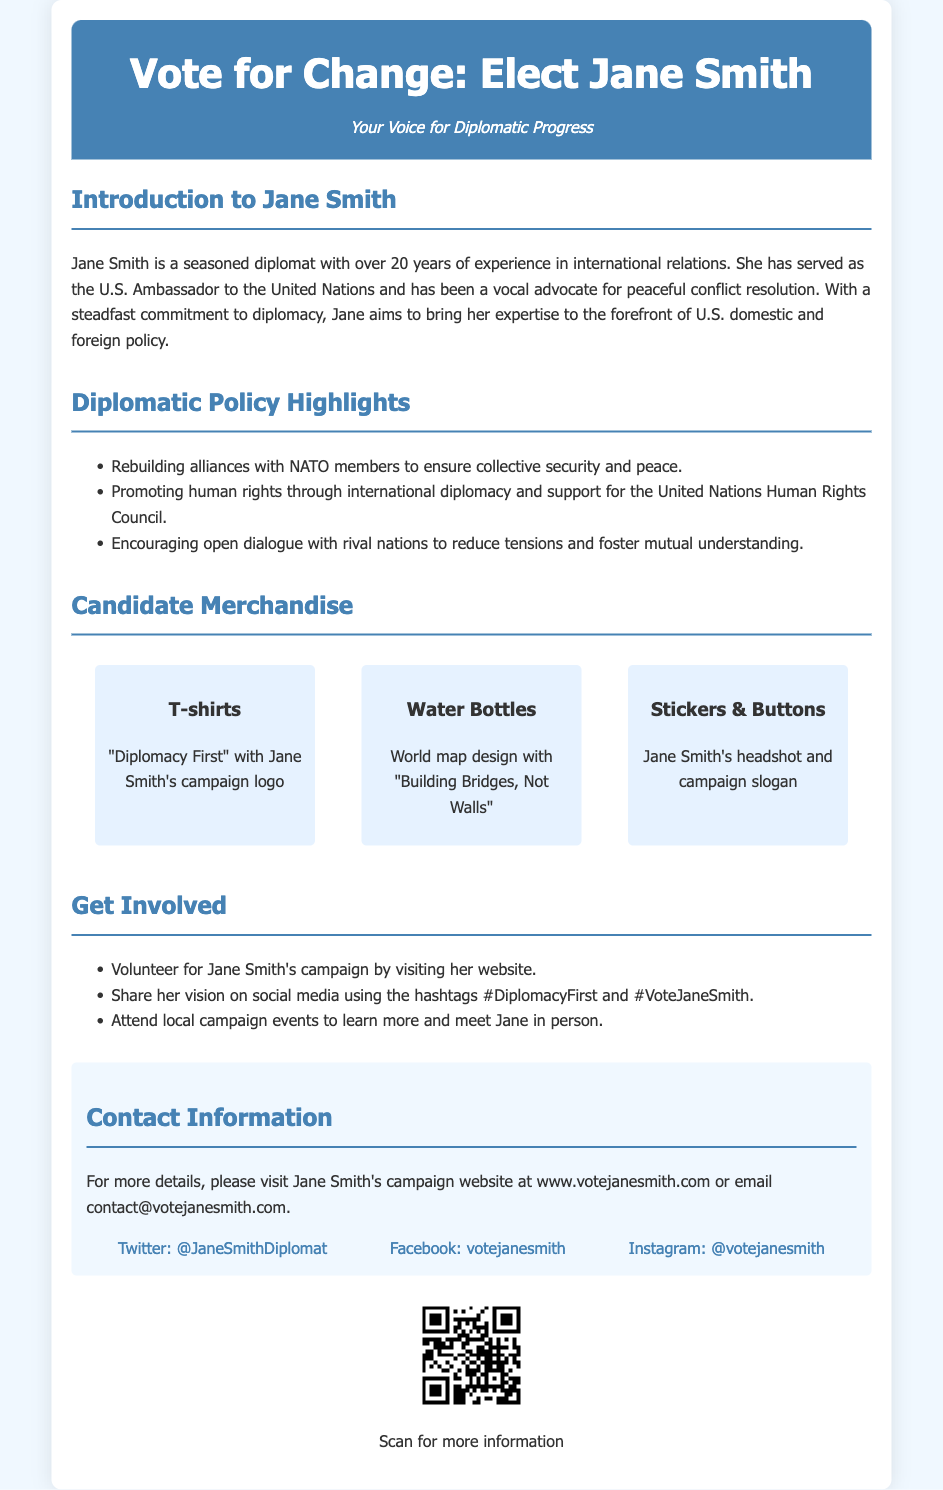What is Jane Smith's campaign slogan? The campaign slogan is prominently displayed in various contexts throughout the document, specifically mentioned as "Diplomacy First."
Answer: Diplomacy First How many years of experience does Jane Smith have in international relations? The document states that Jane Smith has over 20 years of experience in international relations.
Answer: 20 years What is one of Jane Smith's diplomatic policy highlights? This information can be found in the list of policy highlights, which includes various focuses such as rebuilding alliances or promoting human rights.
Answer: Rebuilding alliances with NATO members What type of merchandise is offered in Jane Smith's campaign? The section on merchandise discusses several items that are being offered to supporters, such as clothing and accessories.
Answer: T-shirts What is Jane Smith's email contact for more information? The document provides a specific email address for contacting Jane Smith's campaign, which can be found in the contact information section.
Answer: contact@votejanesmith.com How can individuals engage with Jane Smith's campaign? The document includes a list of actions that supporters can take to get involved in the campaign, such as volunteering and attending events.
Answer: Volunteer for Jane Smith's campaign What is the color of the header background in the document? The header is visually distinct with a specific color mentioned in the style section which can be described as a shade of blue.
Answer: #4682b4 What is the QR code meant for? The document mentions that the QR code serves a specific function which is to provide more information when scanned.
Answer: Scan for more information 